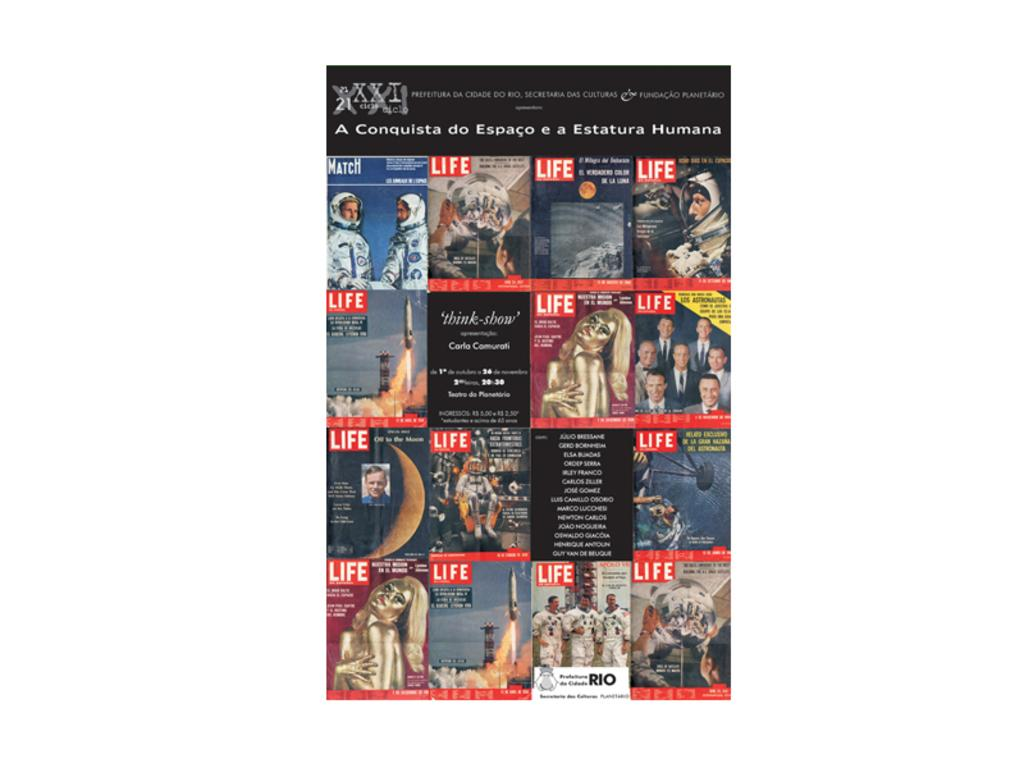<image>
Offer a succinct explanation of the picture presented. An image showing a collage of various Life Magazine covers. 